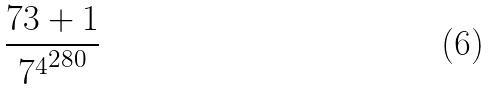<formula> <loc_0><loc_0><loc_500><loc_500>\frac { 7 3 + 1 } { { 7 ^ { 4 } } ^ { 2 8 0 } }</formula> 